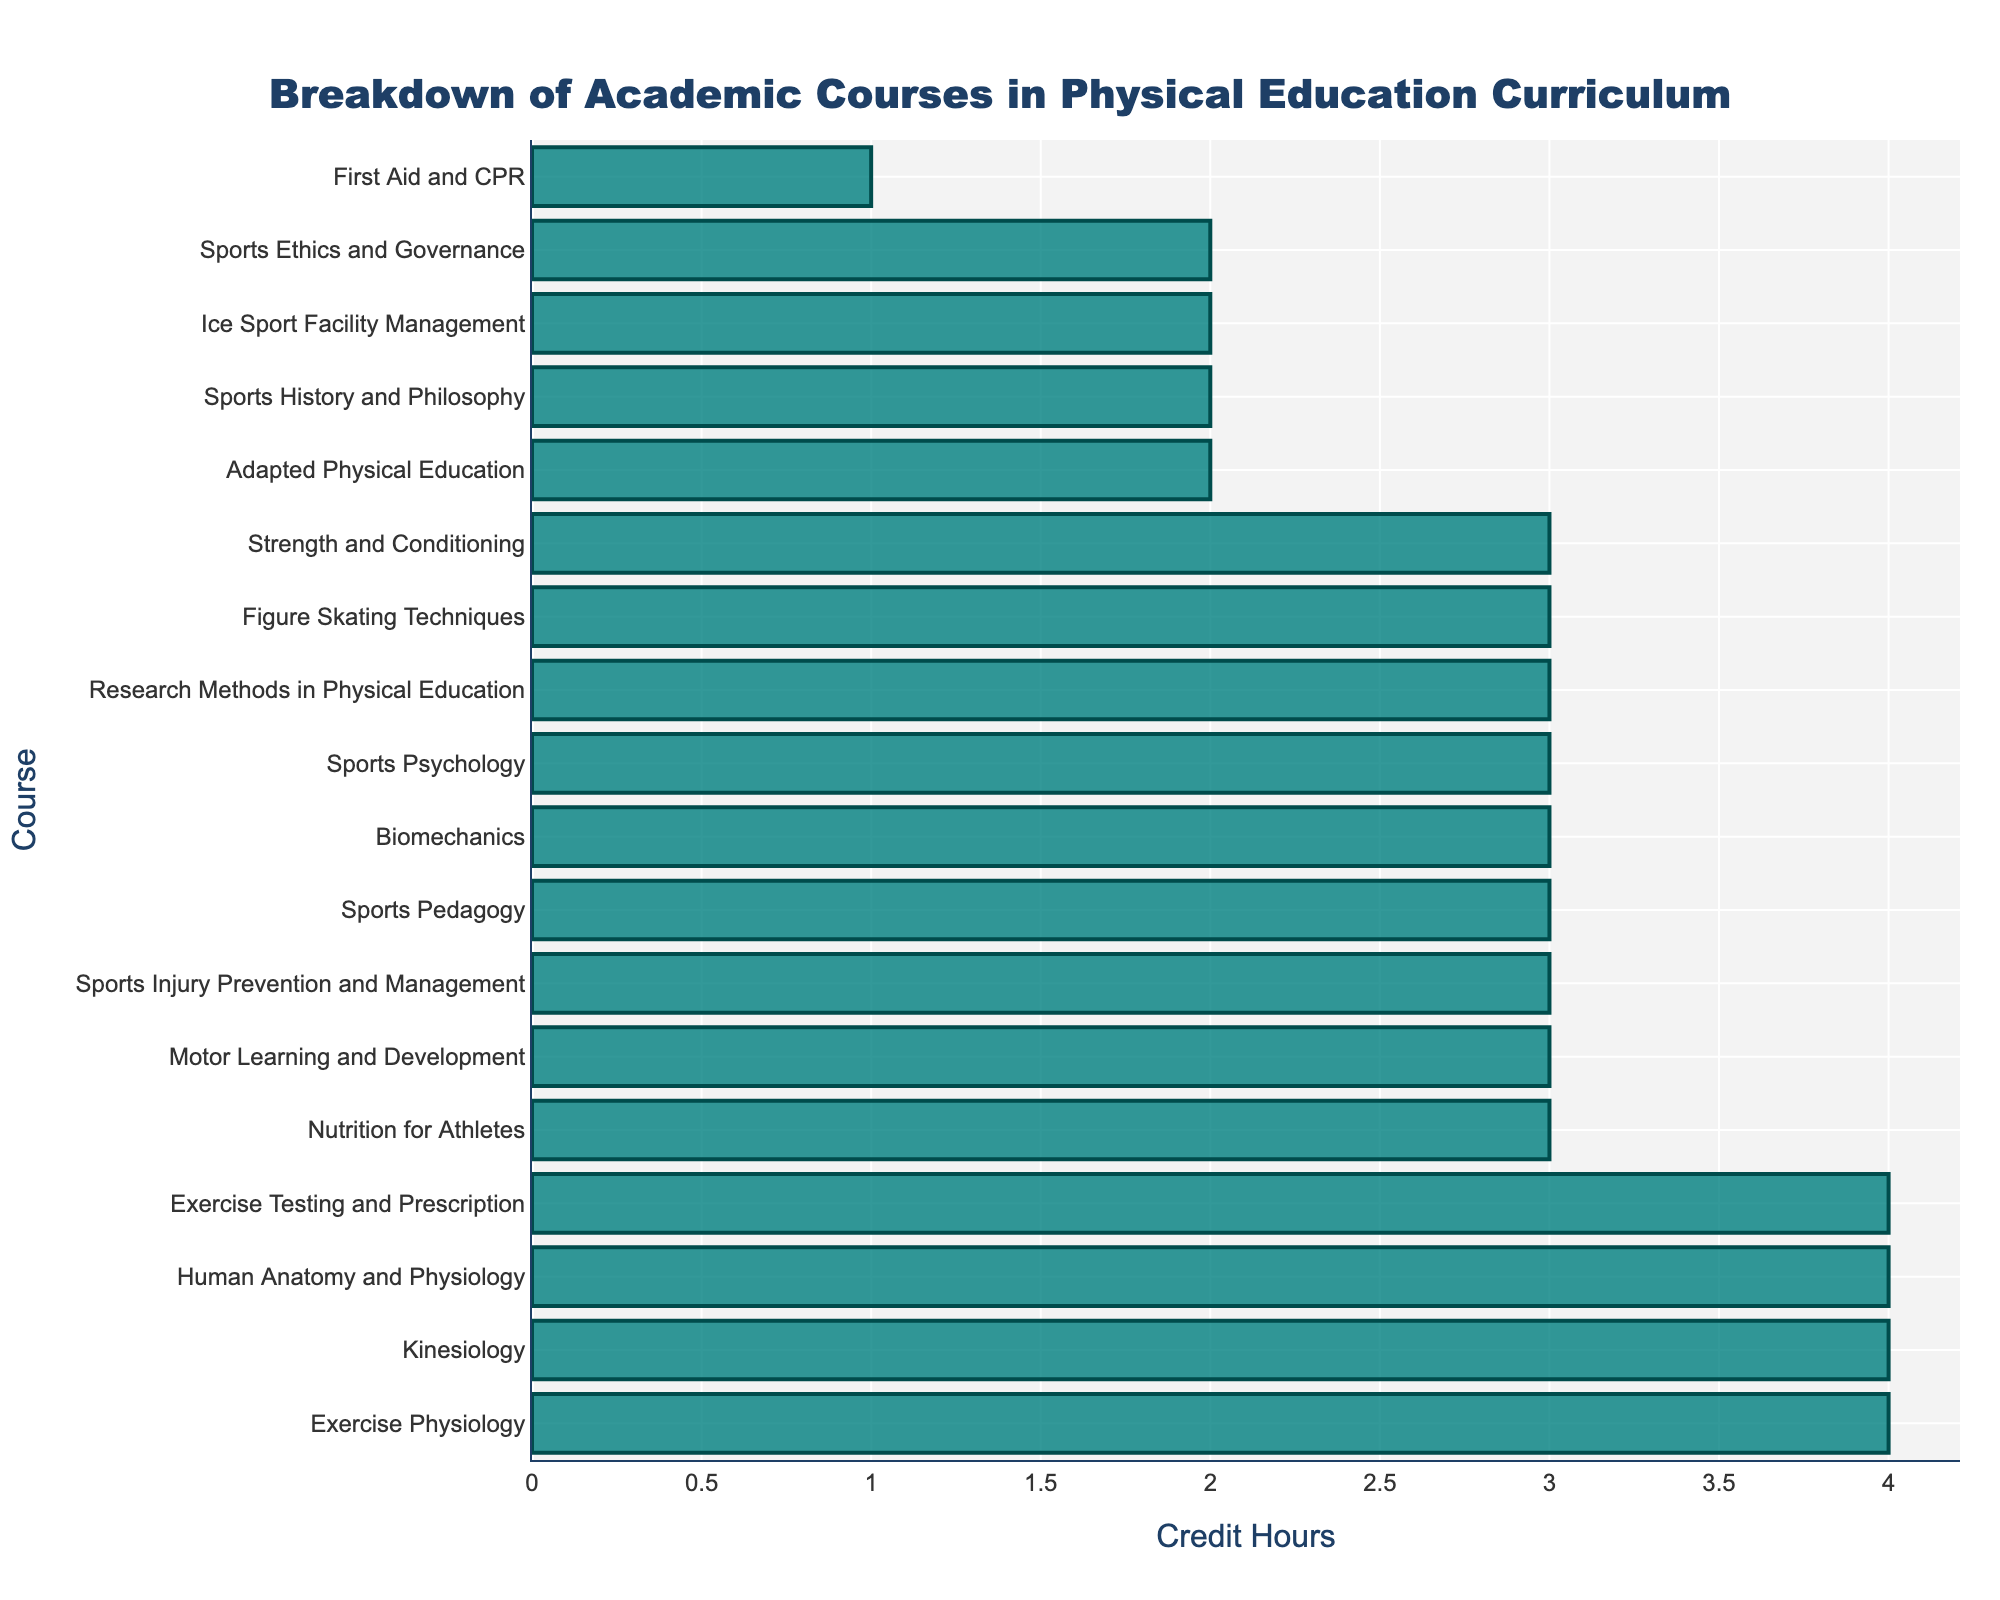What are the three courses with the highest credit hours? Identify the courses with the largest bars in the chart. The three highest are Exercise Physiology, Kinesiology, and Exercise Testing and Prescription, each assigned 4 credit hours.
Answer: Exercise Physiology, Kinesiology, Exercise Testing and Prescription Which course has the lowest credit hours and how many credit hours does it have? Locate the shortest bar. The course with the lowest bar is First Aid and CPR, which has 1 credit hour.
Answer: First Aid and CPR, 1 How many courses have 3 credit hours? Count the number of bars that reach the 3-credit hour mark. The courses that have 3 credit hours are Biomechanics, Sports Psychology, Nutrition for Athletes, Motor Learning and Development, Sports Injury Prevention and Management, Sports Pedagogy, Research Methods in Physical Education, Figure Skating Techniques, and Strength and Conditioning. There are 9 such courses.
Answer: 9 What is the total number of credit hours for all courses combined? Sum the credit hours of all the courses listed. The total is 4 + 3 + 3 + 4 + 3 + 3 + 3 + 2 + 3 + 4 + 4 + 2 + 3 + 3 + 2 + 3 + 1 + 2 = 48.
Answer: 48 Which courses have exactly 2 credit hours and what is their combined credit hour total? Identify the bars reaching the 2-credit hour mark. The courses are Adapted Physical Education, Sports History and Philosophy, Ice Sport Facility Management, and Sports Ethics and Governance. Their combined total is 2 + 2 + 2 + 2 = 8 credit hours.
Answer: Adapted Physical Education, Sports History and Philosophy, Ice Sport Facility Management, Sports Ethics and Governance; 8 How many courses have more than 3 credit hours? Count the number of bars that go beyond the 3-credit hour mark. The courses are Exercise Physiology, Kinesiology, Exercise Testing and Prescription, and Human Anatomy and Physiology. There are 4 such courses.
Answer: 4 How many total credit hours are assigned to kinesiology and biomechanics courses combined? Identify the credit hours for each course separately, then sum them. Kinesiology has 4 credit hours, and Biomechanics has 3 credit hours. Their combined total is 4 + 3 = 7.
Answer: 7 Which course related to figure skating is included in the curriculum and how many credit hours is it assigned? Locate the course named Figure Skating Techniques in the chart. It is assigned 3 credit hours.
Answer: Figure Skating Techniques, 3 Which course has the same credit hours as Sports Psychology and what are those credit hours? Identify the course with the same bar length as Sports Psychology. Both Nutrition for Athletes and Motor Learning and Development have the same credit hours as Sports Psychology, which is 3 credit hours.
Answer: Nutrition for Athletes, Motor Learning and Development; 3 